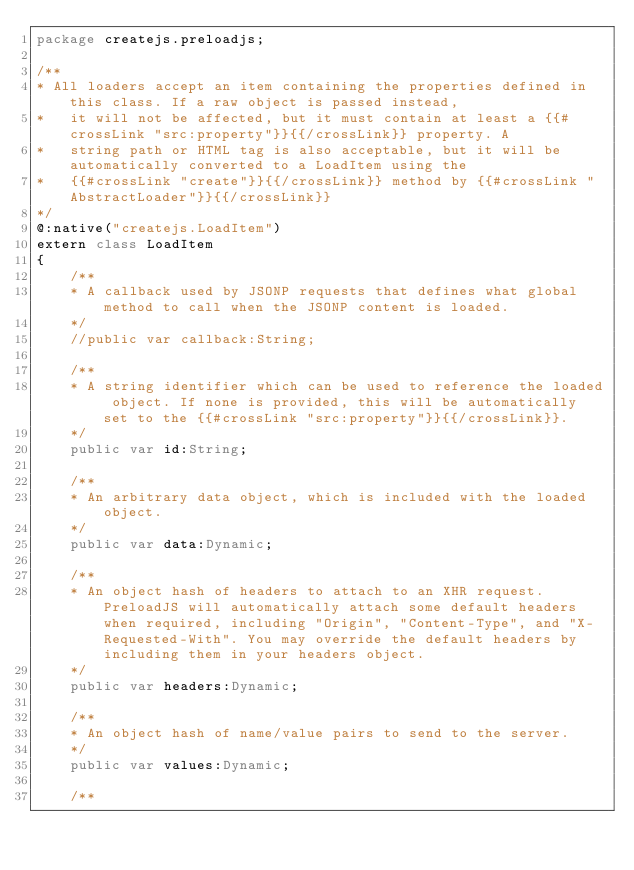<code> <loc_0><loc_0><loc_500><loc_500><_Haxe_>package createjs.preloadjs;

/**
* All loaders accept an item containing the properties defined in this class. If a raw object is passed instead,
*	it will not be affected, but it must contain at least a {{#crossLink "src:property"}}{{/crossLink}} property. A
*	string path or HTML tag is also acceptable, but it will be automatically converted to a LoadItem using the
*	{{#crossLink "create"}}{{/crossLink}} method by {{#crossLink "AbstractLoader"}}{{/crossLink}}
*/
@:native("createjs.LoadItem")
extern class LoadItem
{
	/**
	* A callback used by JSONP requests that defines what global method to call when the JSONP content is loaded.
	*/
	//public var callback:String;
	
	/**
	* A string identifier which can be used to reference the loaded object. If none is provided, this will be automatically set to the {{#crossLink "src:property"}}{{/crossLink}}.
	*/
	public var id:String;
	
	/**
	* An arbitrary data object, which is included with the loaded object.
	*/
	public var data:Dynamic;
	
	/**
	* An object hash of headers to attach to an XHR request. PreloadJS will automatically attach some default headers when required, including "Origin", "Content-Type", and "X-Requested-With". You may override the default headers by including them in your headers object.
	*/
	public var headers:Dynamic;
	
	/**
	* An object hash of name/value pairs to send to the server.
	*/
	public var values:Dynamic;
	
	/**</code> 